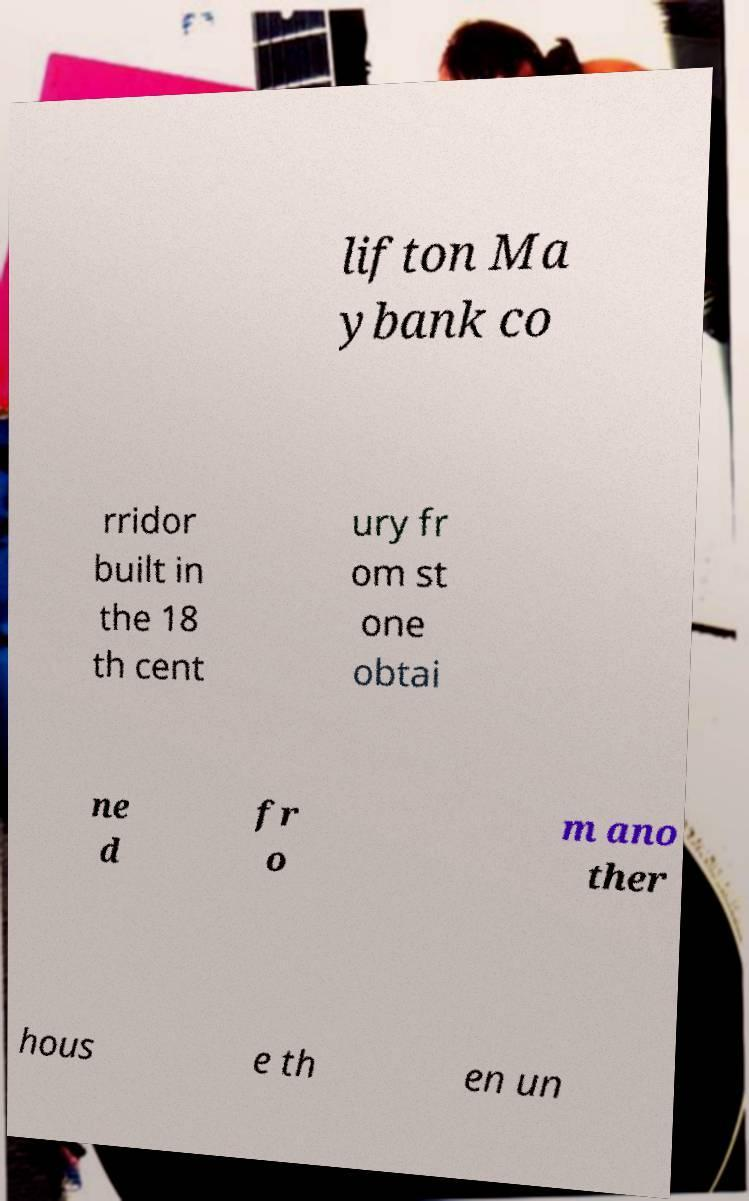Can you read and provide the text displayed in the image?This photo seems to have some interesting text. Can you extract and type it out for me? lifton Ma ybank co rridor built in the 18 th cent ury fr om st one obtai ne d fr o m ano ther hous e th en un 